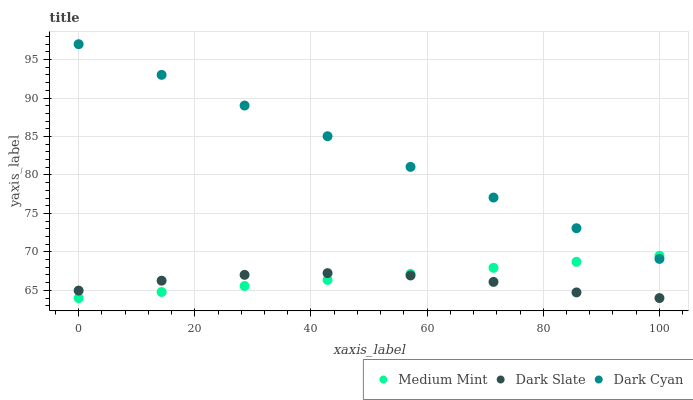Does Dark Slate have the minimum area under the curve?
Answer yes or no. Yes. Does Dark Cyan have the maximum area under the curve?
Answer yes or no. Yes. Does Dark Cyan have the minimum area under the curve?
Answer yes or no. No. Does Dark Slate have the maximum area under the curve?
Answer yes or no. No. Is Dark Cyan the smoothest?
Answer yes or no. Yes. Is Dark Slate the roughest?
Answer yes or no. Yes. Is Dark Slate the smoothest?
Answer yes or no. No. Is Dark Cyan the roughest?
Answer yes or no. No. Does Medium Mint have the lowest value?
Answer yes or no. Yes. Does Dark Cyan have the lowest value?
Answer yes or no. No. Does Dark Cyan have the highest value?
Answer yes or no. Yes. Does Dark Slate have the highest value?
Answer yes or no. No. Is Dark Slate less than Dark Cyan?
Answer yes or no. Yes. Is Dark Cyan greater than Dark Slate?
Answer yes or no. Yes. Does Dark Slate intersect Medium Mint?
Answer yes or no. Yes. Is Dark Slate less than Medium Mint?
Answer yes or no. No. Is Dark Slate greater than Medium Mint?
Answer yes or no. No. Does Dark Slate intersect Dark Cyan?
Answer yes or no. No. 